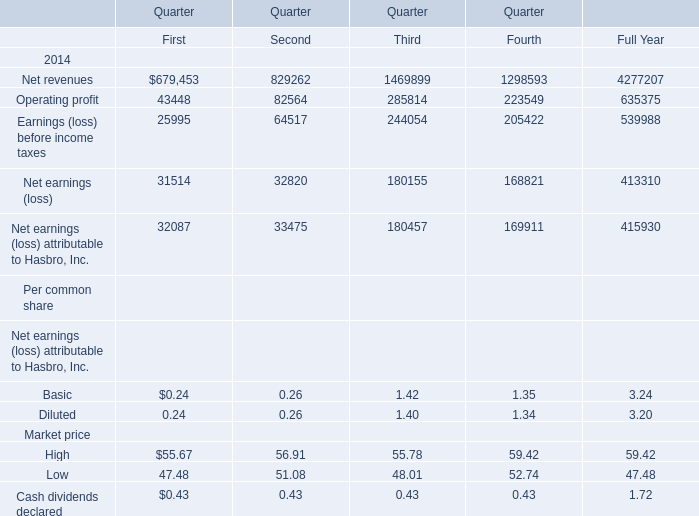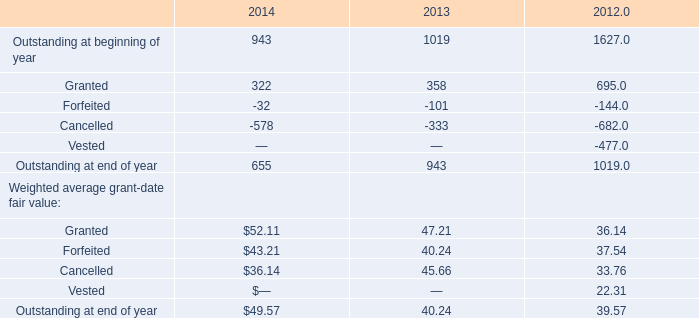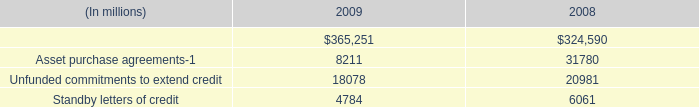In which quarter is Net revenues larger than 1460000 in 2014? 
Answer: 3. 